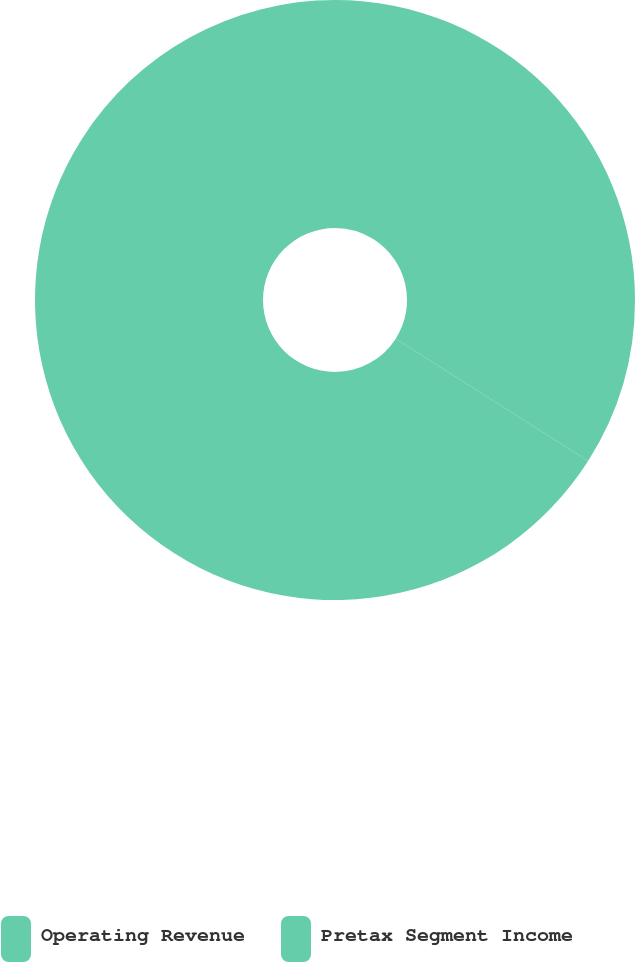<chart> <loc_0><loc_0><loc_500><loc_500><pie_chart><fcel>Operating Revenue<fcel>Pretax Segment Income<nl><fcel>34.02%<fcel>65.98%<nl></chart> 